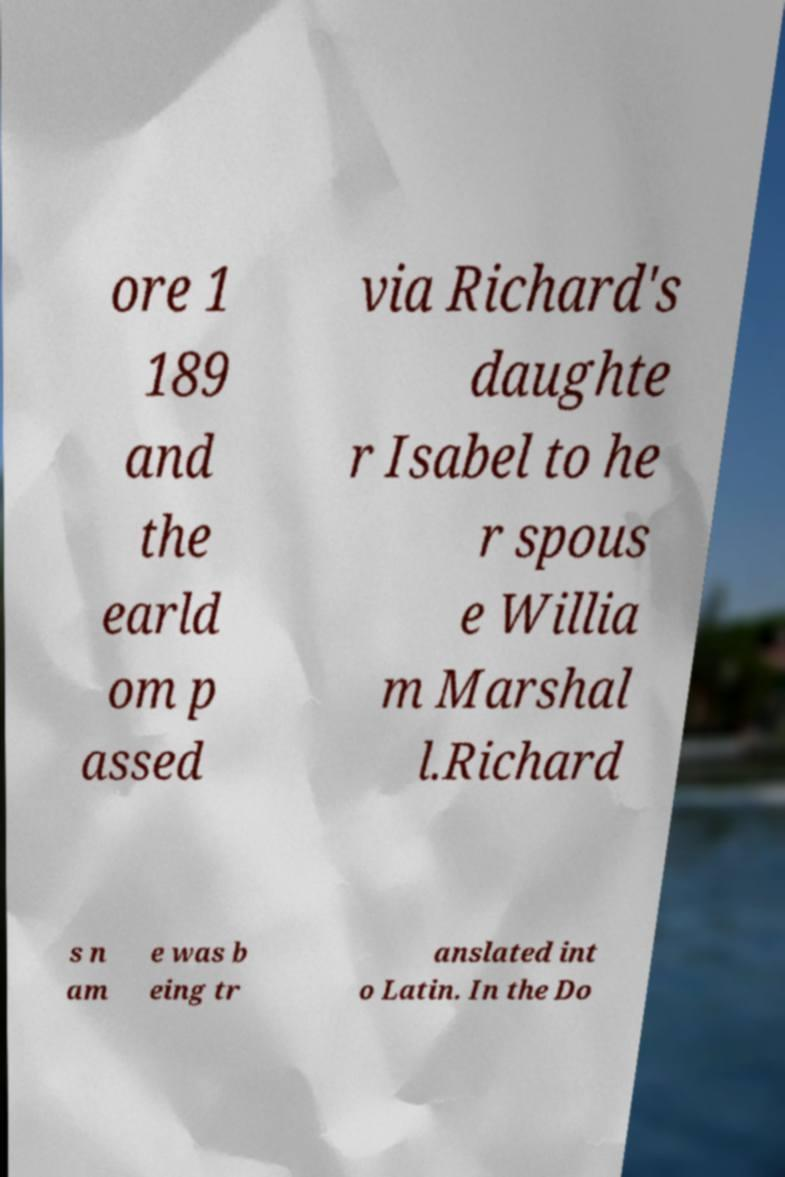What messages or text are displayed in this image? I need them in a readable, typed format. ore 1 189 and the earld om p assed via Richard's daughte r Isabel to he r spous e Willia m Marshal l.Richard s n am e was b eing tr anslated int o Latin. In the Do 